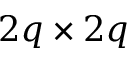Convert formula to latex. <formula><loc_0><loc_0><loc_500><loc_500>2 q \times 2 q</formula> 